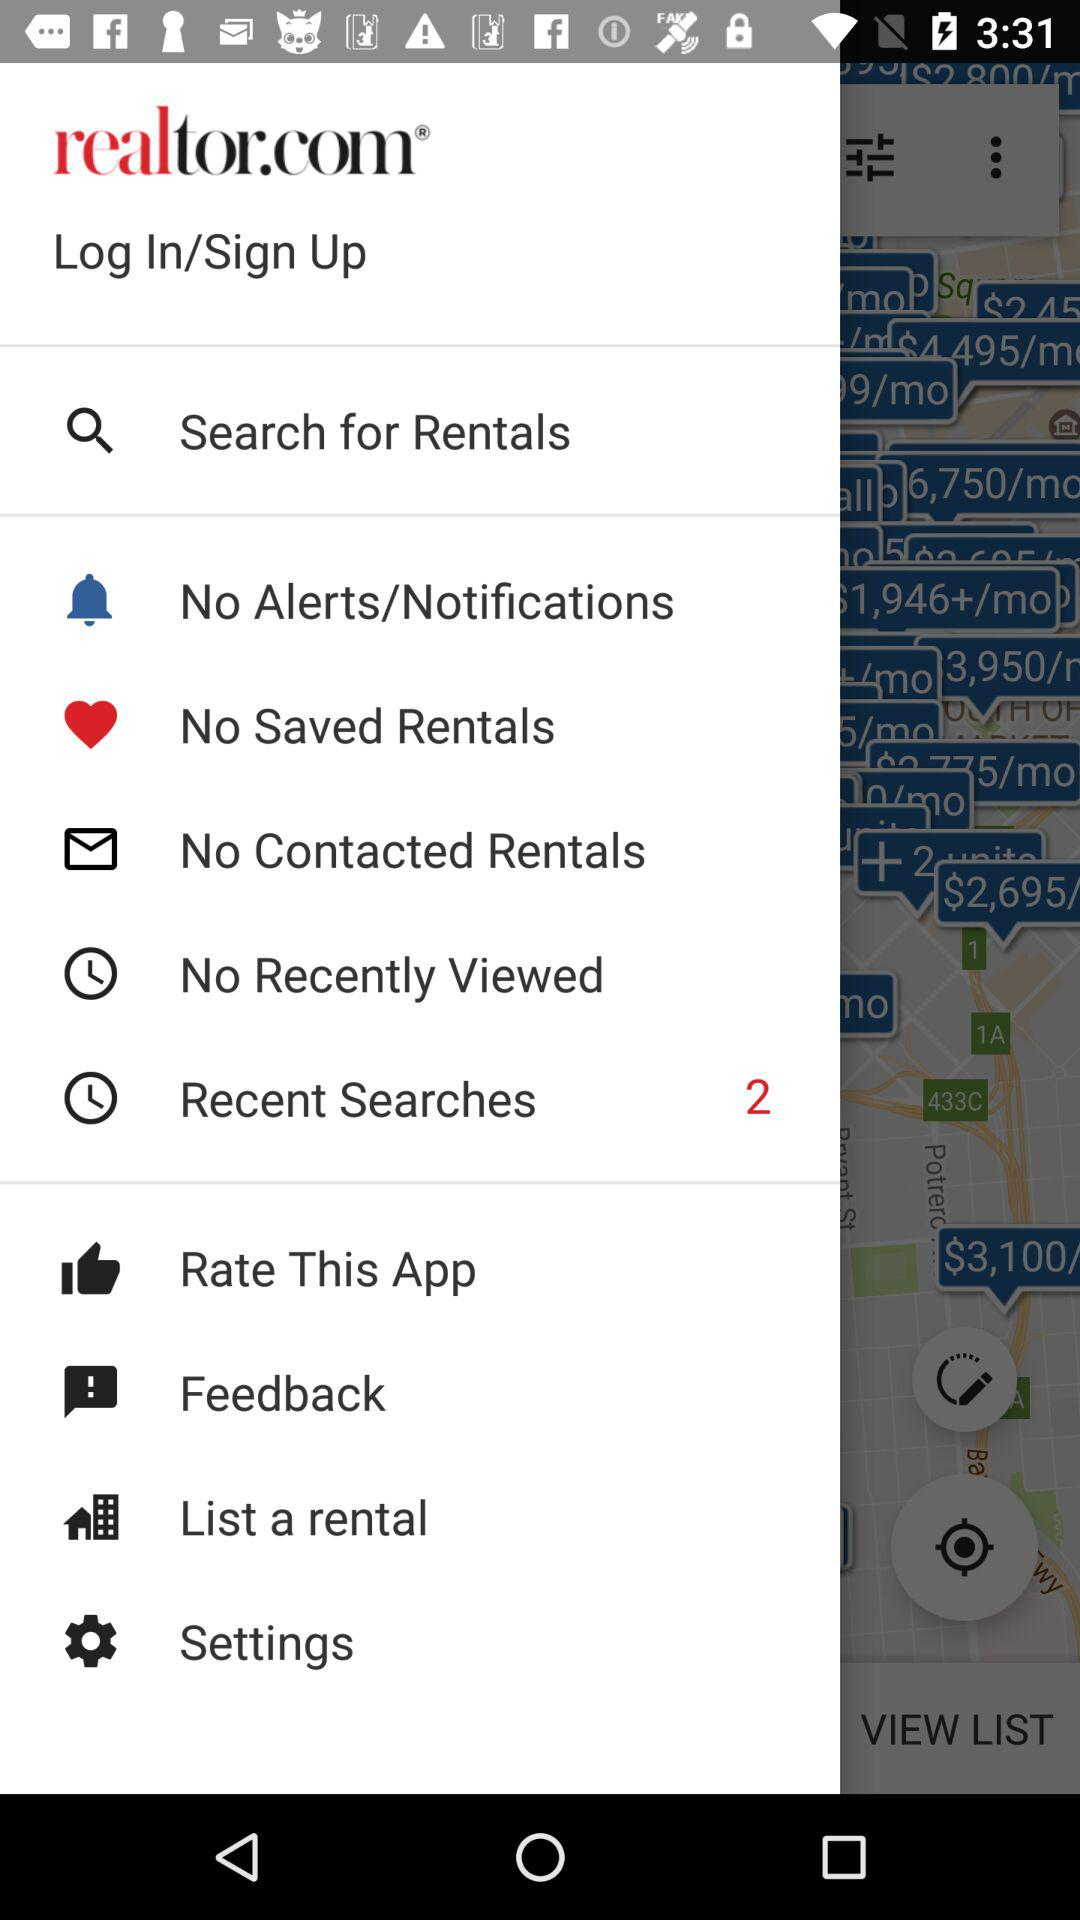How many recent searches has given? There are 2 recent searches given. 